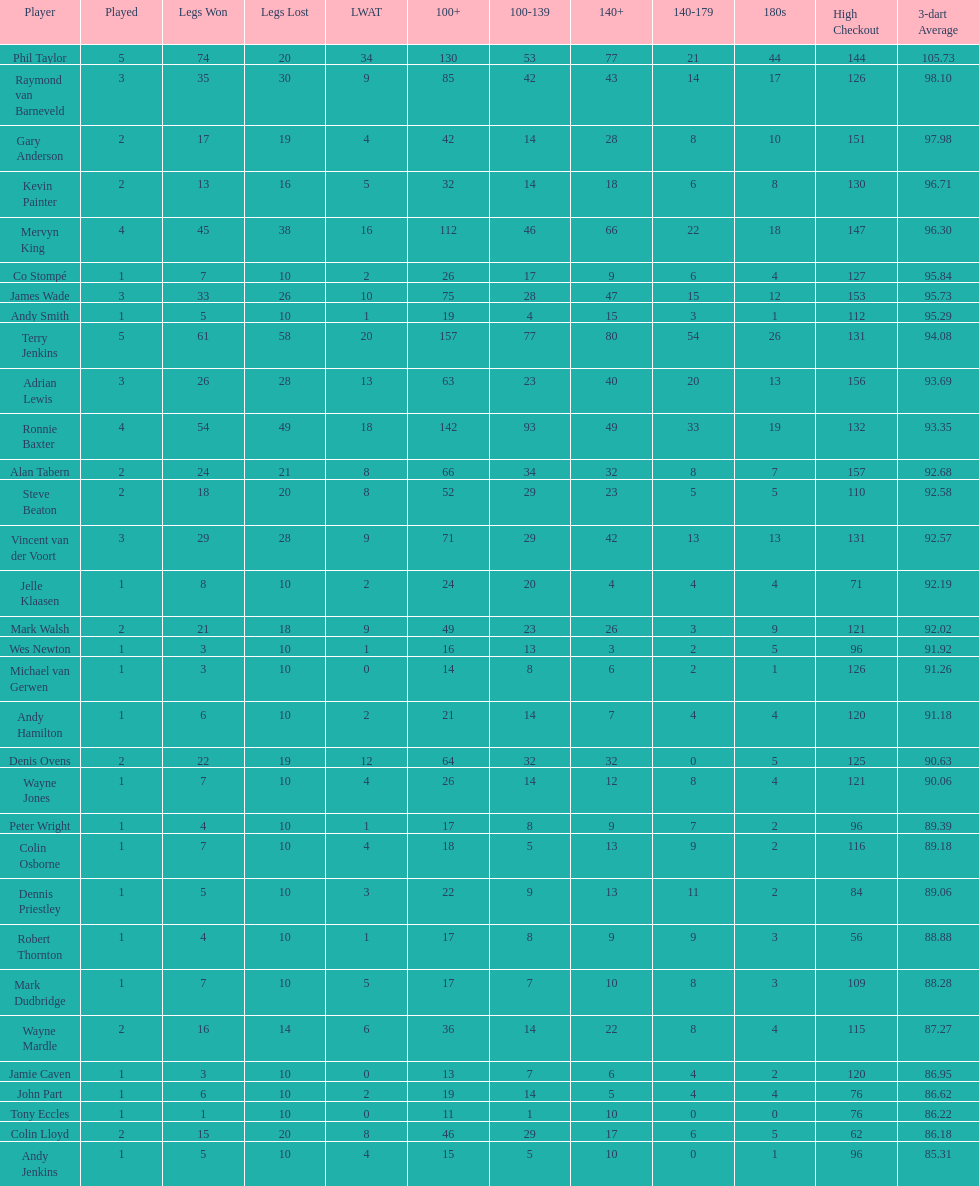What is the name of the next player after mark walsh? Wes Newton. 